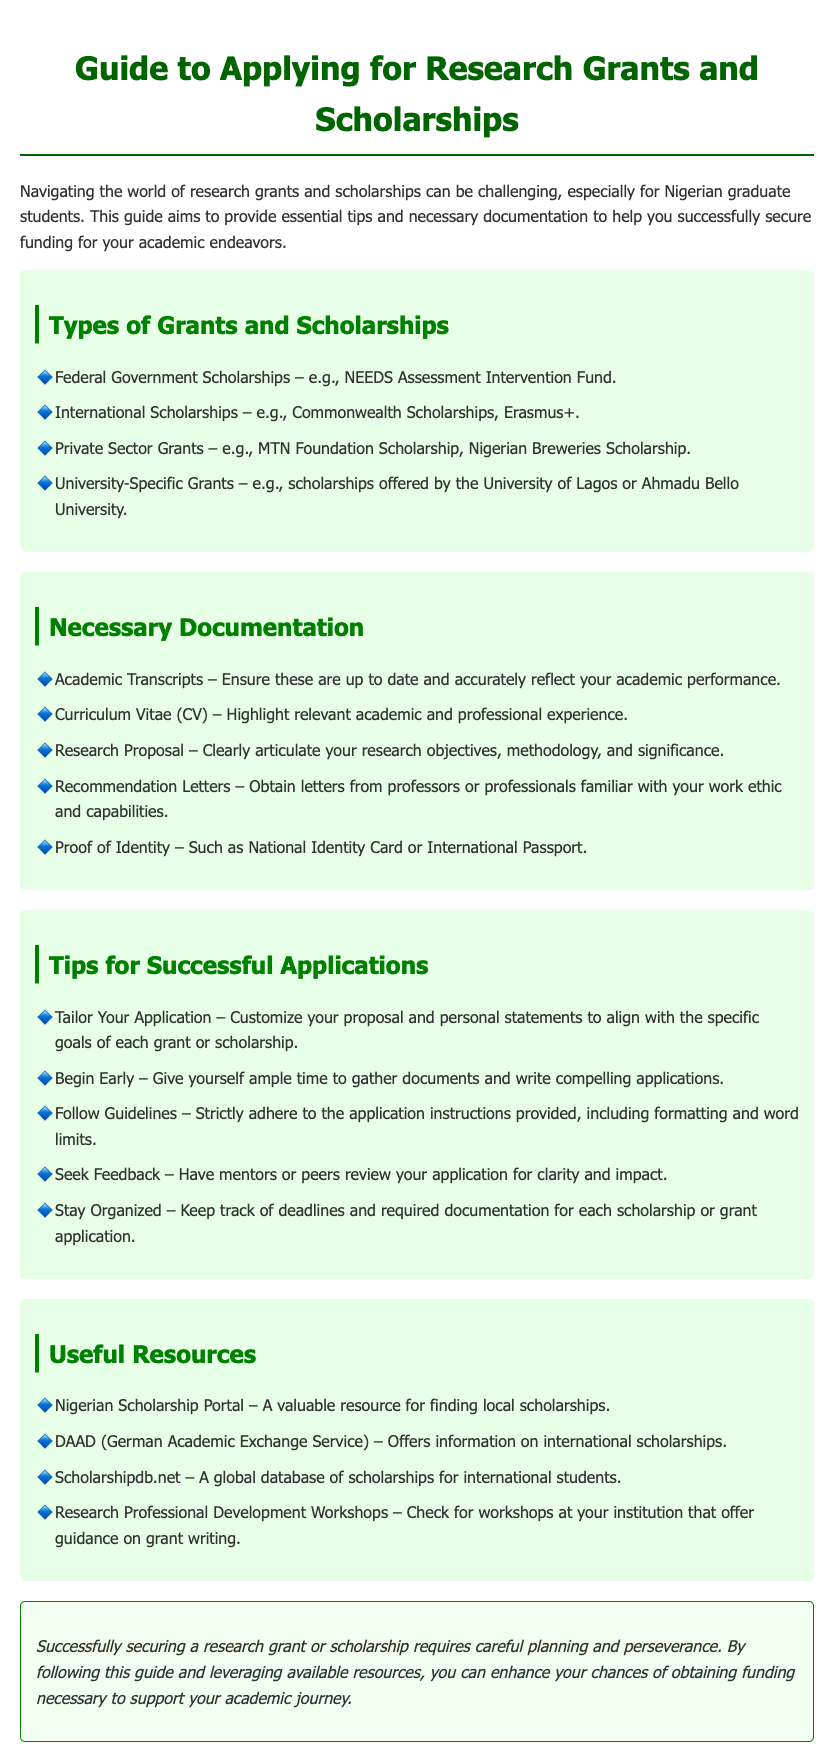What are the types of scholarships listed? The document lists specific types of grants and scholarships available to students, such as government and international scholarships.
Answer: Federal Government Scholarships, International Scholarships, Private Sector Grants, University-Specific Grants What is one necessary document for applying? The document specifies important documentation needed for grant or scholarship applications, including academic records.
Answer: Academic Transcripts How many tips for successful applications are mentioned? The document provides a list of tips aimed at helping applicants improve their chances of success.
Answer: Five What should you tailor your application to? The document emphasizes the importance of personalizing application content based on specific criteria.
Answer: Goals of each grant or scholarship What does the conclusion emphasize for securing funding? The conclusion provides a succinct summary of what is needed for successful applications in terms of planning and resources.
Answer: Planning and perseverance Which organization is mentioned for international scholarship information? The document lists resources to help students find scholarships, including specific organizations.
Answer: DAAD (German Academic Exchange Service) 